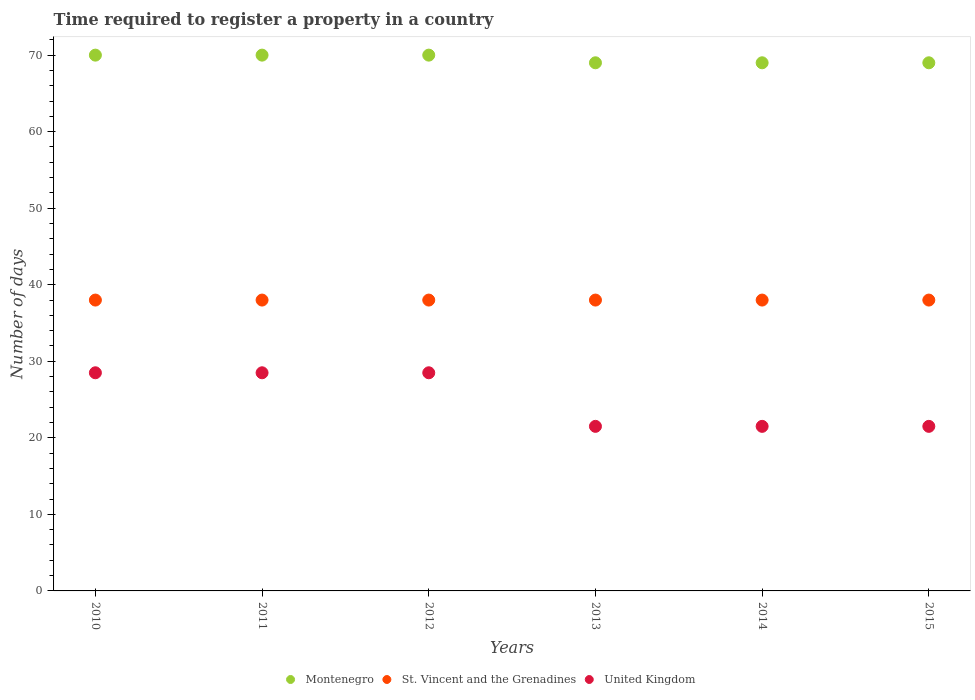How many different coloured dotlines are there?
Make the answer very short. 3. What is the number of days required to register a property in United Kingdom in 2011?
Ensure brevity in your answer.  28.5. Across all years, what is the maximum number of days required to register a property in United Kingdom?
Your answer should be very brief. 28.5. Across all years, what is the minimum number of days required to register a property in St. Vincent and the Grenadines?
Ensure brevity in your answer.  38. What is the total number of days required to register a property in United Kingdom in the graph?
Give a very brief answer. 150. What is the difference between the number of days required to register a property in Montenegro in 2010 and that in 2011?
Your answer should be very brief. 0. What is the ratio of the number of days required to register a property in Montenegro in 2010 to that in 2013?
Your answer should be compact. 1.01. Is the difference between the number of days required to register a property in Montenegro in 2010 and 2013 greater than the difference between the number of days required to register a property in St. Vincent and the Grenadines in 2010 and 2013?
Provide a succinct answer. Yes. What is the difference between the highest and the lowest number of days required to register a property in Montenegro?
Provide a succinct answer. 1. Is it the case that in every year, the sum of the number of days required to register a property in United Kingdom and number of days required to register a property in Montenegro  is greater than the number of days required to register a property in St. Vincent and the Grenadines?
Your answer should be compact. Yes. Is the number of days required to register a property in St. Vincent and the Grenadines strictly greater than the number of days required to register a property in Montenegro over the years?
Your answer should be very brief. No. How many dotlines are there?
Your response must be concise. 3. Are the values on the major ticks of Y-axis written in scientific E-notation?
Your answer should be very brief. No. Does the graph contain any zero values?
Provide a succinct answer. No. Does the graph contain grids?
Keep it short and to the point. No. What is the title of the graph?
Keep it short and to the point. Time required to register a property in a country. Does "Comoros" appear as one of the legend labels in the graph?
Give a very brief answer. No. What is the label or title of the X-axis?
Offer a terse response. Years. What is the label or title of the Y-axis?
Keep it short and to the point. Number of days. What is the Number of days of Montenegro in 2010?
Ensure brevity in your answer.  70. What is the Number of days in United Kingdom in 2011?
Give a very brief answer. 28.5. What is the Number of days of Montenegro in 2012?
Give a very brief answer. 70. What is the Number of days of United Kingdom in 2012?
Make the answer very short. 28.5. What is the Number of days of Montenegro in 2013?
Provide a succinct answer. 69. What is the Number of days of St. Vincent and the Grenadines in 2013?
Offer a terse response. 38. What is the Number of days of United Kingdom in 2014?
Offer a very short reply. 21.5. What is the Number of days of Montenegro in 2015?
Your answer should be compact. 69. What is the Number of days in United Kingdom in 2015?
Offer a terse response. 21.5. Across all years, what is the maximum Number of days in Montenegro?
Offer a very short reply. 70. Across all years, what is the maximum Number of days in United Kingdom?
Keep it short and to the point. 28.5. Across all years, what is the minimum Number of days of Montenegro?
Provide a succinct answer. 69. Across all years, what is the minimum Number of days in St. Vincent and the Grenadines?
Offer a very short reply. 38. Across all years, what is the minimum Number of days in United Kingdom?
Keep it short and to the point. 21.5. What is the total Number of days of Montenegro in the graph?
Give a very brief answer. 417. What is the total Number of days in St. Vincent and the Grenadines in the graph?
Keep it short and to the point. 228. What is the total Number of days of United Kingdom in the graph?
Ensure brevity in your answer.  150. What is the difference between the Number of days of Montenegro in 2010 and that in 2012?
Give a very brief answer. 0. What is the difference between the Number of days in St. Vincent and the Grenadines in 2010 and that in 2012?
Your answer should be compact. 0. What is the difference between the Number of days of United Kingdom in 2010 and that in 2013?
Your answer should be very brief. 7. What is the difference between the Number of days of Montenegro in 2010 and that in 2014?
Keep it short and to the point. 1. What is the difference between the Number of days of St. Vincent and the Grenadines in 2010 and that in 2015?
Give a very brief answer. 0. What is the difference between the Number of days in United Kingdom in 2010 and that in 2015?
Keep it short and to the point. 7. What is the difference between the Number of days of Montenegro in 2011 and that in 2012?
Make the answer very short. 0. What is the difference between the Number of days in United Kingdom in 2011 and that in 2012?
Provide a succinct answer. 0. What is the difference between the Number of days of Montenegro in 2011 and that in 2013?
Provide a succinct answer. 1. What is the difference between the Number of days of United Kingdom in 2011 and that in 2013?
Provide a short and direct response. 7. What is the difference between the Number of days in St. Vincent and the Grenadines in 2011 and that in 2014?
Your response must be concise. 0. What is the difference between the Number of days of United Kingdom in 2011 and that in 2014?
Ensure brevity in your answer.  7. What is the difference between the Number of days of Montenegro in 2011 and that in 2015?
Your response must be concise. 1. What is the difference between the Number of days of St. Vincent and the Grenadines in 2011 and that in 2015?
Your answer should be compact. 0. What is the difference between the Number of days of Montenegro in 2012 and that in 2013?
Offer a very short reply. 1. What is the difference between the Number of days of Montenegro in 2012 and that in 2014?
Provide a succinct answer. 1. What is the difference between the Number of days in United Kingdom in 2012 and that in 2014?
Offer a very short reply. 7. What is the difference between the Number of days in United Kingdom in 2012 and that in 2015?
Your answer should be compact. 7. What is the difference between the Number of days of United Kingdom in 2013 and that in 2015?
Offer a very short reply. 0. What is the difference between the Number of days of Montenegro in 2014 and that in 2015?
Give a very brief answer. 0. What is the difference between the Number of days of St. Vincent and the Grenadines in 2014 and that in 2015?
Your answer should be compact. 0. What is the difference between the Number of days of United Kingdom in 2014 and that in 2015?
Offer a very short reply. 0. What is the difference between the Number of days of Montenegro in 2010 and the Number of days of United Kingdom in 2011?
Provide a short and direct response. 41.5. What is the difference between the Number of days in Montenegro in 2010 and the Number of days in St. Vincent and the Grenadines in 2012?
Your answer should be compact. 32. What is the difference between the Number of days in Montenegro in 2010 and the Number of days in United Kingdom in 2012?
Provide a short and direct response. 41.5. What is the difference between the Number of days of St. Vincent and the Grenadines in 2010 and the Number of days of United Kingdom in 2012?
Offer a terse response. 9.5. What is the difference between the Number of days of Montenegro in 2010 and the Number of days of St. Vincent and the Grenadines in 2013?
Your answer should be compact. 32. What is the difference between the Number of days in Montenegro in 2010 and the Number of days in United Kingdom in 2013?
Offer a terse response. 48.5. What is the difference between the Number of days of Montenegro in 2010 and the Number of days of St. Vincent and the Grenadines in 2014?
Keep it short and to the point. 32. What is the difference between the Number of days in Montenegro in 2010 and the Number of days in United Kingdom in 2014?
Offer a very short reply. 48.5. What is the difference between the Number of days of Montenegro in 2010 and the Number of days of United Kingdom in 2015?
Keep it short and to the point. 48.5. What is the difference between the Number of days in Montenegro in 2011 and the Number of days in United Kingdom in 2012?
Your response must be concise. 41.5. What is the difference between the Number of days in St. Vincent and the Grenadines in 2011 and the Number of days in United Kingdom in 2012?
Your answer should be compact. 9.5. What is the difference between the Number of days in Montenegro in 2011 and the Number of days in United Kingdom in 2013?
Give a very brief answer. 48.5. What is the difference between the Number of days of Montenegro in 2011 and the Number of days of United Kingdom in 2014?
Make the answer very short. 48.5. What is the difference between the Number of days in Montenegro in 2011 and the Number of days in United Kingdom in 2015?
Your answer should be compact. 48.5. What is the difference between the Number of days in Montenegro in 2012 and the Number of days in St. Vincent and the Grenadines in 2013?
Your answer should be very brief. 32. What is the difference between the Number of days in Montenegro in 2012 and the Number of days in United Kingdom in 2013?
Make the answer very short. 48.5. What is the difference between the Number of days of Montenegro in 2012 and the Number of days of St. Vincent and the Grenadines in 2014?
Offer a terse response. 32. What is the difference between the Number of days in Montenegro in 2012 and the Number of days in United Kingdom in 2014?
Your response must be concise. 48.5. What is the difference between the Number of days of Montenegro in 2012 and the Number of days of United Kingdom in 2015?
Provide a succinct answer. 48.5. What is the difference between the Number of days of Montenegro in 2013 and the Number of days of St. Vincent and the Grenadines in 2014?
Offer a very short reply. 31. What is the difference between the Number of days of Montenegro in 2013 and the Number of days of United Kingdom in 2014?
Your answer should be very brief. 47.5. What is the difference between the Number of days in Montenegro in 2013 and the Number of days in St. Vincent and the Grenadines in 2015?
Your answer should be very brief. 31. What is the difference between the Number of days in Montenegro in 2013 and the Number of days in United Kingdom in 2015?
Make the answer very short. 47.5. What is the difference between the Number of days of Montenegro in 2014 and the Number of days of St. Vincent and the Grenadines in 2015?
Keep it short and to the point. 31. What is the difference between the Number of days in Montenegro in 2014 and the Number of days in United Kingdom in 2015?
Provide a succinct answer. 47.5. What is the average Number of days in Montenegro per year?
Your answer should be compact. 69.5. What is the average Number of days in St. Vincent and the Grenadines per year?
Provide a short and direct response. 38. In the year 2010, what is the difference between the Number of days in Montenegro and Number of days in United Kingdom?
Provide a short and direct response. 41.5. In the year 2011, what is the difference between the Number of days of Montenegro and Number of days of United Kingdom?
Your answer should be compact. 41.5. In the year 2012, what is the difference between the Number of days in Montenegro and Number of days in St. Vincent and the Grenadines?
Offer a very short reply. 32. In the year 2012, what is the difference between the Number of days of Montenegro and Number of days of United Kingdom?
Make the answer very short. 41.5. In the year 2013, what is the difference between the Number of days in Montenegro and Number of days in United Kingdom?
Give a very brief answer. 47.5. In the year 2013, what is the difference between the Number of days in St. Vincent and the Grenadines and Number of days in United Kingdom?
Your answer should be compact. 16.5. In the year 2014, what is the difference between the Number of days in Montenegro and Number of days in St. Vincent and the Grenadines?
Ensure brevity in your answer.  31. In the year 2014, what is the difference between the Number of days in Montenegro and Number of days in United Kingdom?
Provide a short and direct response. 47.5. In the year 2014, what is the difference between the Number of days in St. Vincent and the Grenadines and Number of days in United Kingdom?
Make the answer very short. 16.5. In the year 2015, what is the difference between the Number of days of Montenegro and Number of days of St. Vincent and the Grenadines?
Offer a very short reply. 31. In the year 2015, what is the difference between the Number of days in Montenegro and Number of days in United Kingdom?
Your answer should be compact. 47.5. What is the ratio of the Number of days of Montenegro in 2010 to that in 2011?
Offer a terse response. 1. What is the ratio of the Number of days in St. Vincent and the Grenadines in 2010 to that in 2011?
Your response must be concise. 1. What is the ratio of the Number of days of United Kingdom in 2010 to that in 2011?
Your response must be concise. 1. What is the ratio of the Number of days of St. Vincent and the Grenadines in 2010 to that in 2012?
Your answer should be compact. 1. What is the ratio of the Number of days of United Kingdom in 2010 to that in 2012?
Provide a short and direct response. 1. What is the ratio of the Number of days of Montenegro in 2010 to that in 2013?
Provide a short and direct response. 1.01. What is the ratio of the Number of days of St. Vincent and the Grenadines in 2010 to that in 2013?
Offer a very short reply. 1. What is the ratio of the Number of days in United Kingdom in 2010 to that in 2013?
Keep it short and to the point. 1.33. What is the ratio of the Number of days in Montenegro in 2010 to that in 2014?
Ensure brevity in your answer.  1.01. What is the ratio of the Number of days of St. Vincent and the Grenadines in 2010 to that in 2014?
Ensure brevity in your answer.  1. What is the ratio of the Number of days of United Kingdom in 2010 to that in 2014?
Give a very brief answer. 1.33. What is the ratio of the Number of days in Montenegro in 2010 to that in 2015?
Give a very brief answer. 1.01. What is the ratio of the Number of days of St. Vincent and the Grenadines in 2010 to that in 2015?
Offer a terse response. 1. What is the ratio of the Number of days in United Kingdom in 2010 to that in 2015?
Ensure brevity in your answer.  1.33. What is the ratio of the Number of days of Montenegro in 2011 to that in 2012?
Provide a succinct answer. 1. What is the ratio of the Number of days of St. Vincent and the Grenadines in 2011 to that in 2012?
Your answer should be compact. 1. What is the ratio of the Number of days in United Kingdom in 2011 to that in 2012?
Make the answer very short. 1. What is the ratio of the Number of days of Montenegro in 2011 to that in 2013?
Provide a short and direct response. 1.01. What is the ratio of the Number of days in St. Vincent and the Grenadines in 2011 to that in 2013?
Offer a terse response. 1. What is the ratio of the Number of days of United Kingdom in 2011 to that in 2013?
Provide a succinct answer. 1.33. What is the ratio of the Number of days of Montenegro in 2011 to that in 2014?
Keep it short and to the point. 1.01. What is the ratio of the Number of days of United Kingdom in 2011 to that in 2014?
Offer a very short reply. 1.33. What is the ratio of the Number of days in Montenegro in 2011 to that in 2015?
Give a very brief answer. 1.01. What is the ratio of the Number of days of United Kingdom in 2011 to that in 2015?
Offer a terse response. 1.33. What is the ratio of the Number of days in Montenegro in 2012 to that in 2013?
Your answer should be very brief. 1.01. What is the ratio of the Number of days in St. Vincent and the Grenadines in 2012 to that in 2013?
Give a very brief answer. 1. What is the ratio of the Number of days in United Kingdom in 2012 to that in 2013?
Provide a short and direct response. 1.33. What is the ratio of the Number of days of Montenegro in 2012 to that in 2014?
Your response must be concise. 1.01. What is the ratio of the Number of days in St. Vincent and the Grenadines in 2012 to that in 2014?
Ensure brevity in your answer.  1. What is the ratio of the Number of days of United Kingdom in 2012 to that in 2014?
Ensure brevity in your answer.  1.33. What is the ratio of the Number of days in Montenegro in 2012 to that in 2015?
Your answer should be compact. 1.01. What is the ratio of the Number of days of United Kingdom in 2012 to that in 2015?
Offer a very short reply. 1.33. What is the ratio of the Number of days of Montenegro in 2013 to that in 2015?
Provide a short and direct response. 1. What is the ratio of the Number of days in St. Vincent and the Grenadines in 2013 to that in 2015?
Offer a very short reply. 1. What is the ratio of the Number of days of United Kingdom in 2013 to that in 2015?
Your answer should be compact. 1. What is the ratio of the Number of days in Montenegro in 2014 to that in 2015?
Offer a very short reply. 1. What is the ratio of the Number of days of United Kingdom in 2014 to that in 2015?
Your response must be concise. 1. What is the difference between the highest and the second highest Number of days in Montenegro?
Keep it short and to the point. 0. What is the difference between the highest and the lowest Number of days in St. Vincent and the Grenadines?
Make the answer very short. 0. What is the difference between the highest and the lowest Number of days of United Kingdom?
Provide a succinct answer. 7. 